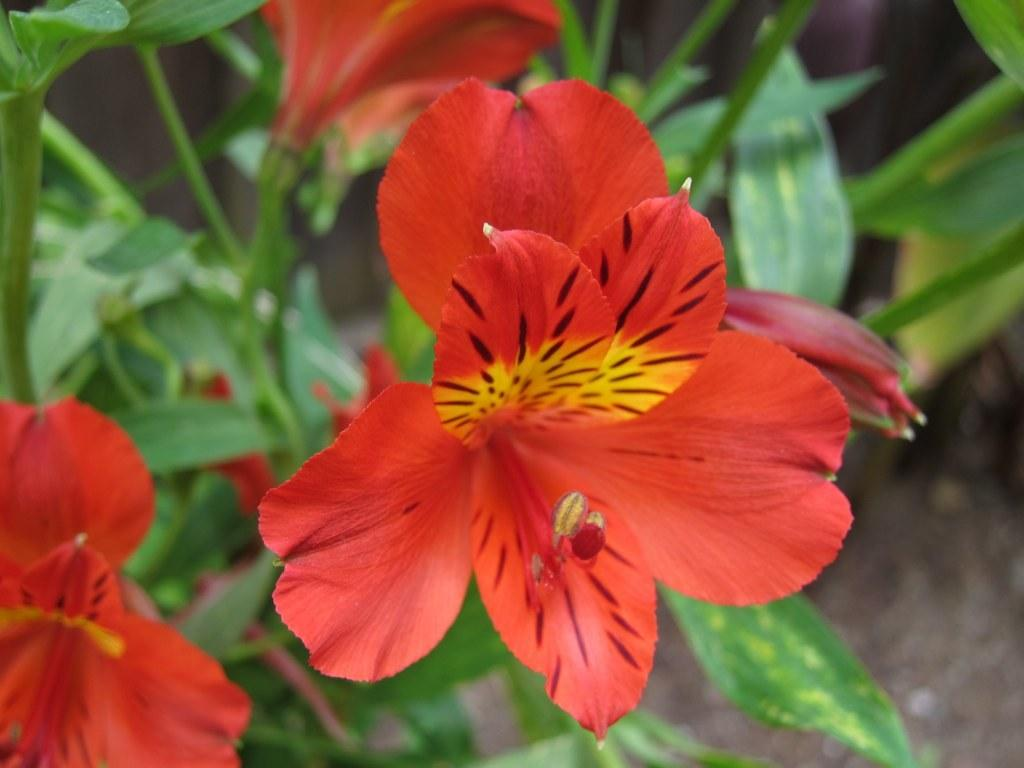What type of plants can be seen in the image? There are flowers and leaves in the image. Can you describe the background of the image? The background of the image is blurred. What type of giants can be seen interacting with the hose in the image? There are no giants or hoses present in the image; it features flowers and leaves with a blurred background. 